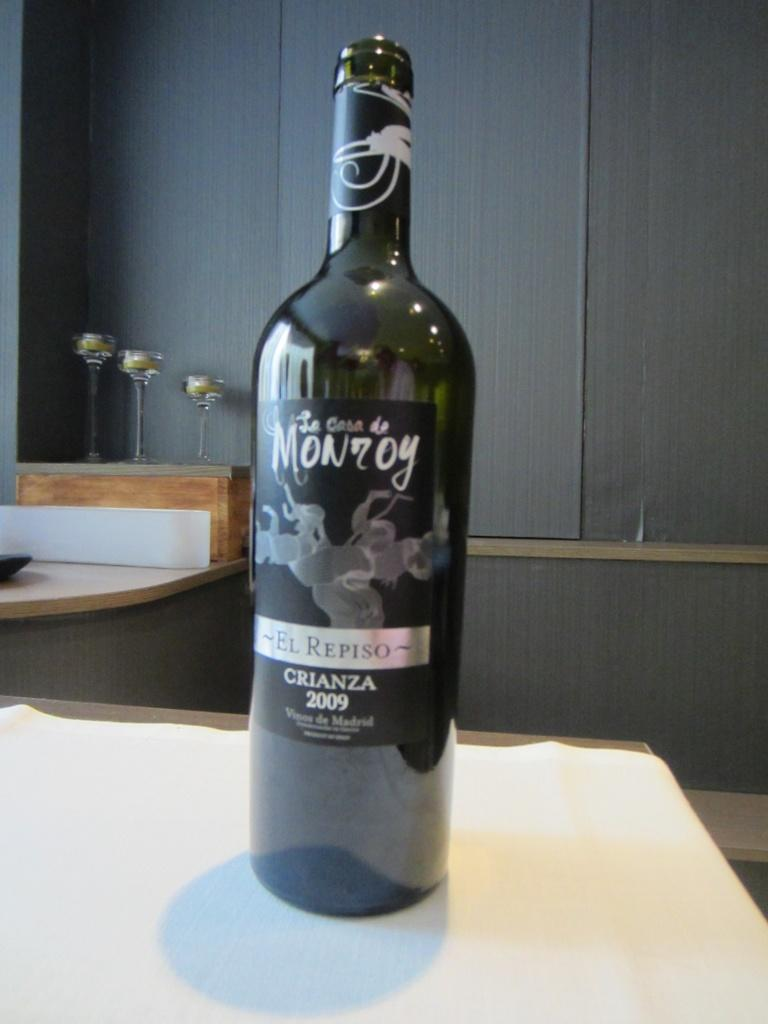What is the main object in the image? There is a wine bottle in the image. What is the wine bottle placed on? The wine bottle is placed on a wooden surface. What can be seen on the wine bottle? The wine bottle has a label. What other items related to wine can be seen in the image? There are wine glasses in the image. What type of material is visible on the wall in the image? There is a wooden wall in the image. How many cakes are stacked on top of the wine bottle in the image? There are no cakes present in the image; it only features a wine bottle, wine glasses, and a wooden wall. 